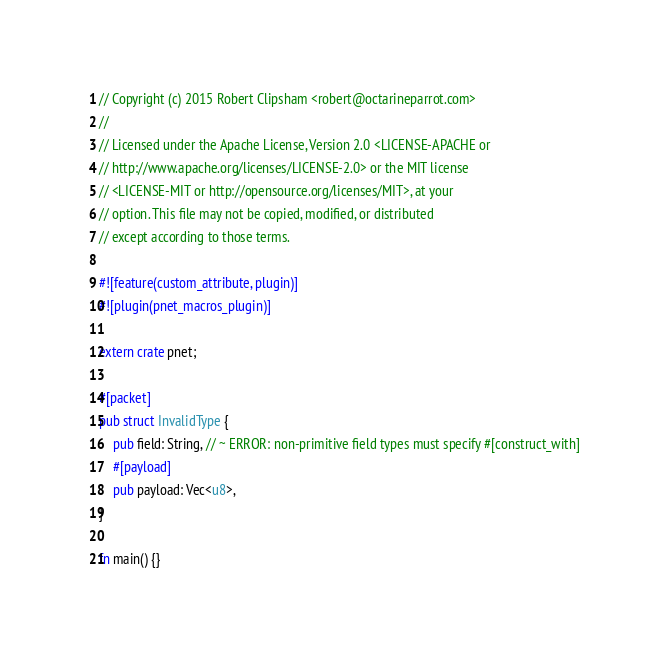<code> <loc_0><loc_0><loc_500><loc_500><_Rust_>// Copyright (c) 2015 Robert Clipsham <robert@octarineparrot.com>
//
// Licensed under the Apache License, Version 2.0 <LICENSE-APACHE or
// http://www.apache.org/licenses/LICENSE-2.0> or the MIT license
// <LICENSE-MIT or http://opensource.org/licenses/MIT>, at your
// option. This file may not be copied, modified, or distributed
// except according to those terms.

#![feature(custom_attribute, plugin)]
#![plugin(pnet_macros_plugin)]

extern crate pnet;

#[packet]
pub struct InvalidType {
    pub field: String, // ~ ERROR: non-primitive field types must specify #[construct_with]
    #[payload]
    pub payload: Vec<u8>,
}

fn main() {}
</code> 